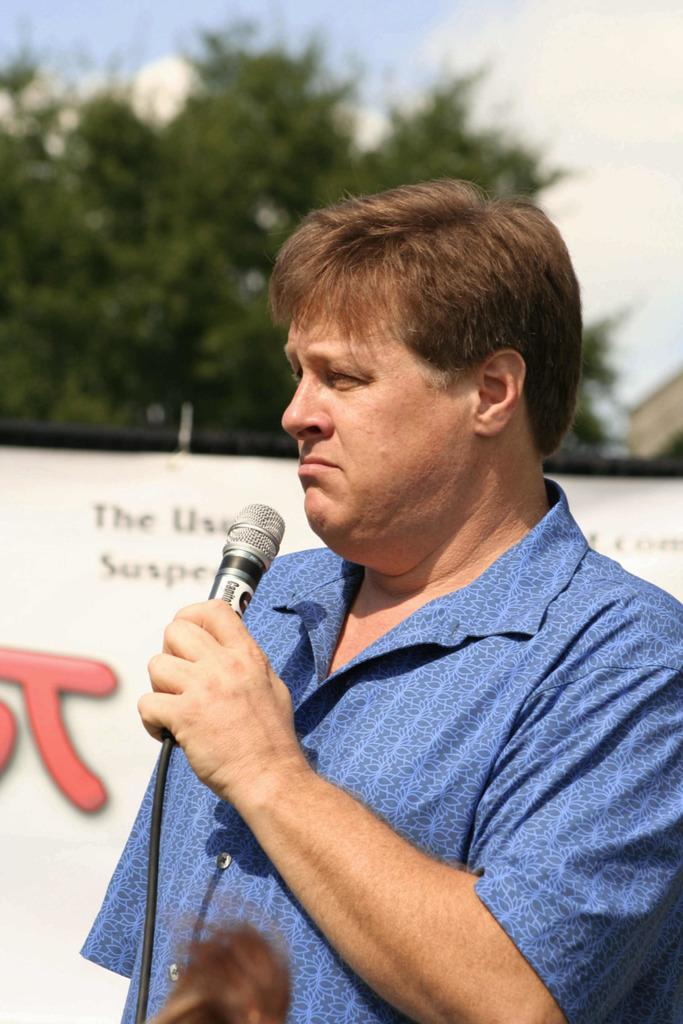Who is present in the image? There is a man in the image. What is the man wearing? The man is wearing a blue shirt. What is the man holding in the image? The man is holding a microphone. What can be seen in the background of the image? There is a banner, a tree, and the sky visible in the background of the image. What type of clam is nesting in the tree in the image? There is no clam or nest present in the image; it features a man holding a microphone with a banner, tree, and sky in the background. 